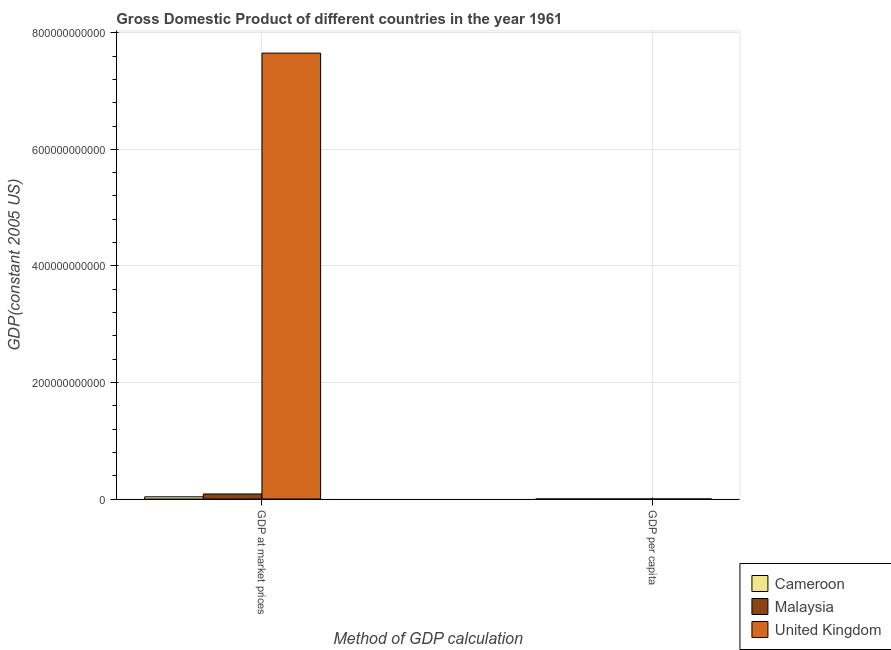Are the number of bars per tick equal to the number of legend labels?
Your response must be concise. Yes. Are the number of bars on each tick of the X-axis equal?
Make the answer very short. Yes. How many bars are there on the 1st tick from the left?
Your answer should be compact. 3. What is the label of the 2nd group of bars from the left?
Offer a very short reply. GDP per capita. What is the gdp at market prices in Cameroon?
Provide a short and direct response. 3.82e+09. Across all countries, what is the maximum gdp at market prices?
Your answer should be very brief. 7.65e+11. Across all countries, what is the minimum gdp at market prices?
Offer a terse response. 3.82e+09. In which country was the gdp at market prices maximum?
Keep it short and to the point. United Kingdom. In which country was the gdp per capita minimum?
Your answer should be very brief. Cameroon. What is the total gdp per capita in the graph?
Provide a succinct answer. 1.62e+04. What is the difference between the gdp per capita in Cameroon and that in Malaysia?
Your response must be concise. -329.27. What is the difference between the gdp per capita in Malaysia and the gdp at market prices in Cameroon?
Provide a succinct answer. -3.82e+09. What is the average gdp per capita per country?
Offer a very short reply. 5405.15. What is the difference between the gdp at market prices and gdp per capita in Malaysia?
Your answer should be compact. 8.66e+09. In how many countries, is the gdp at market prices greater than 720000000000 US$?
Ensure brevity in your answer.  1. What is the ratio of the gdp at market prices in Malaysia to that in Cameroon?
Your answer should be compact. 2.27. Is the gdp at market prices in Cameroon less than that in Malaysia?
Your answer should be compact. Yes. What does the 3rd bar from the left in GDP per capita represents?
Ensure brevity in your answer.  United Kingdom. What does the 3rd bar from the right in GDP per capita represents?
Provide a short and direct response. Cameroon. How many bars are there?
Provide a short and direct response. 6. Are all the bars in the graph horizontal?
Your answer should be very brief. No. What is the difference between two consecutive major ticks on the Y-axis?
Keep it short and to the point. 2.00e+11. Are the values on the major ticks of Y-axis written in scientific E-notation?
Offer a terse response. No. Does the graph contain any zero values?
Make the answer very short. No. How many legend labels are there?
Provide a short and direct response. 3. What is the title of the graph?
Your answer should be very brief. Gross Domestic Product of different countries in the year 1961. What is the label or title of the X-axis?
Make the answer very short. Method of GDP calculation. What is the label or title of the Y-axis?
Your answer should be compact. GDP(constant 2005 US). What is the GDP(constant 2005 US) of Cameroon in GDP at market prices?
Your answer should be very brief. 3.82e+09. What is the GDP(constant 2005 US) of Malaysia in GDP at market prices?
Give a very brief answer. 8.66e+09. What is the GDP(constant 2005 US) in United Kingdom in GDP at market prices?
Your answer should be compact. 7.65e+11. What is the GDP(constant 2005 US) of Cameroon in GDP per capita?
Give a very brief answer. 698.37. What is the GDP(constant 2005 US) of Malaysia in GDP per capita?
Provide a short and direct response. 1027.64. What is the GDP(constant 2005 US) in United Kingdom in GDP per capita?
Provide a short and direct response. 1.45e+04. Across all Method of GDP calculation, what is the maximum GDP(constant 2005 US) in Cameroon?
Your answer should be very brief. 3.82e+09. Across all Method of GDP calculation, what is the maximum GDP(constant 2005 US) of Malaysia?
Offer a terse response. 8.66e+09. Across all Method of GDP calculation, what is the maximum GDP(constant 2005 US) in United Kingdom?
Give a very brief answer. 7.65e+11. Across all Method of GDP calculation, what is the minimum GDP(constant 2005 US) in Cameroon?
Make the answer very short. 698.37. Across all Method of GDP calculation, what is the minimum GDP(constant 2005 US) of Malaysia?
Offer a terse response. 1027.64. Across all Method of GDP calculation, what is the minimum GDP(constant 2005 US) in United Kingdom?
Keep it short and to the point. 1.45e+04. What is the total GDP(constant 2005 US) of Cameroon in the graph?
Give a very brief answer. 3.82e+09. What is the total GDP(constant 2005 US) in Malaysia in the graph?
Keep it short and to the point. 8.66e+09. What is the total GDP(constant 2005 US) of United Kingdom in the graph?
Offer a very short reply. 7.65e+11. What is the difference between the GDP(constant 2005 US) of Cameroon in GDP at market prices and that in GDP per capita?
Provide a short and direct response. 3.82e+09. What is the difference between the GDP(constant 2005 US) of Malaysia in GDP at market prices and that in GDP per capita?
Provide a short and direct response. 8.66e+09. What is the difference between the GDP(constant 2005 US) in United Kingdom in GDP at market prices and that in GDP per capita?
Offer a terse response. 7.65e+11. What is the difference between the GDP(constant 2005 US) of Cameroon in GDP at market prices and the GDP(constant 2005 US) of Malaysia in GDP per capita?
Offer a terse response. 3.82e+09. What is the difference between the GDP(constant 2005 US) of Cameroon in GDP at market prices and the GDP(constant 2005 US) of United Kingdom in GDP per capita?
Ensure brevity in your answer.  3.82e+09. What is the difference between the GDP(constant 2005 US) of Malaysia in GDP at market prices and the GDP(constant 2005 US) of United Kingdom in GDP per capita?
Provide a short and direct response. 8.66e+09. What is the average GDP(constant 2005 US) in Cameroon per Method of GDP calculation?
Provide a short and direct response. 1.91e+09. What is the average GDP(constant 2005 US) in Malaysia per Method of GDP calculation?
Ensure brevity in your answer.  4.33e+09. What is the average GDP(constant 2005 US) in United Kingdom per Method of GDP calculation?
Offer a very short reply. 3.83e+11. What is the difference between the GDP(constant 2005 US) of Cameroon and GDP(constant 2005 US) of Malaysia in GDP at market prices?
Your answer should be very brief. -4.84e+09. What is the difference between the GDP(constant 2005 US) of Cameroon and GDP(constant 2005 US) of United Kingdom in GDP at market prices?
Make the answer very short. -7.61e+11. What is the difference between the GDP(constant 2005 US) of Malaysia and GDP(constant 2005 US) of United Kingdom in GDP at market prices?
Provide a short and direct response. -7.56e+11. What is the difference between the GDP(constant 2005 US) in Cameroon and GDP(constant 2005 US) in Malaysia in GDP per capita?
Offer a terse response. -329.27. What is the difference between the GDP(constant 2005 US) in Cameroon and GDP(constant 2005 US) in United Kingdom in GDP per capita?
Make the answer very short. -1.38e+04. What is the difference between the GDP(constant 2005 US) of Malaysia and GDP(constant 2005 US) of United Kingdom in GDP per capita?
Your answer should be compact. -1.35e+04. What is the ratio of the GDP(constant 2005 US) in Cameroon in GDP at market prices to that in GDP per capita?
Provide a succinct answer. 5.47e+06. What is the ratio of the GDP(constant 2005 US) in Malaysia in GDP at market prices to that in GDP per capita?
Provide a succinct answer. 8.43e+06. What is the ratio of the GDP(constant 2005 US) of United Kingdom in GDP at market prices to that in GDP per capita?
Make the answer very short. 5.28e+07. What is the difference between the highest and the second highest GDP(constant 2005 US) of Cameroon?
Your response must be concise. 3.82e+09. What is the difference between the highest and the second highest GDP(constant 2005 US) of Malaysia?
Ensure brevity in your answer.  8.66e+09. What is the difference between the highest and the second highest GDP(constant 2005 US) of United Kingdom?
Ensure brevity in your answer.  7.65e+11. What is the difference between the highest and the lowest GDP(constant 2005 US) in Cameroon?
Make the answer very short. 3.82e+09. What is the difference between the highest and the lowest GDP(constant 2005 US) of Malaysia?
Offer a very short reply. 8.66e+09. What is the difference between the highest and the lowest GDP(constant 2005 US) in United Kingdom?
Give a very brief answer. 7.65e+11. 